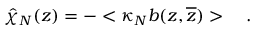Convert formula to latex. <formula><loc_0><loc_0><loc_500><loc_500>\hat { \chi } _ { N } ( z ) = - < \kappa _ { N } b ( z , \overline { z } ) > \quad .</formula> 